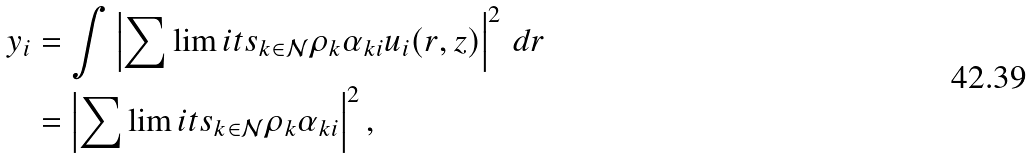<formula> <loc_0><loc_0><loc_500><loc_500>y _ { i } & = \int \left | \sum \lim i t s _ { k \in \mathcal { N } } \rho _ { k } \alpha _ { k i } u _ { i } ( r , z ) \right | ^ { 2 } \, d r \\ & = \left | \sum \lim i t s _ { k \in \mathcal { N } } \rho _ { k } \alpha _ { k i } \right | ^ { 2 } ,</formula> 